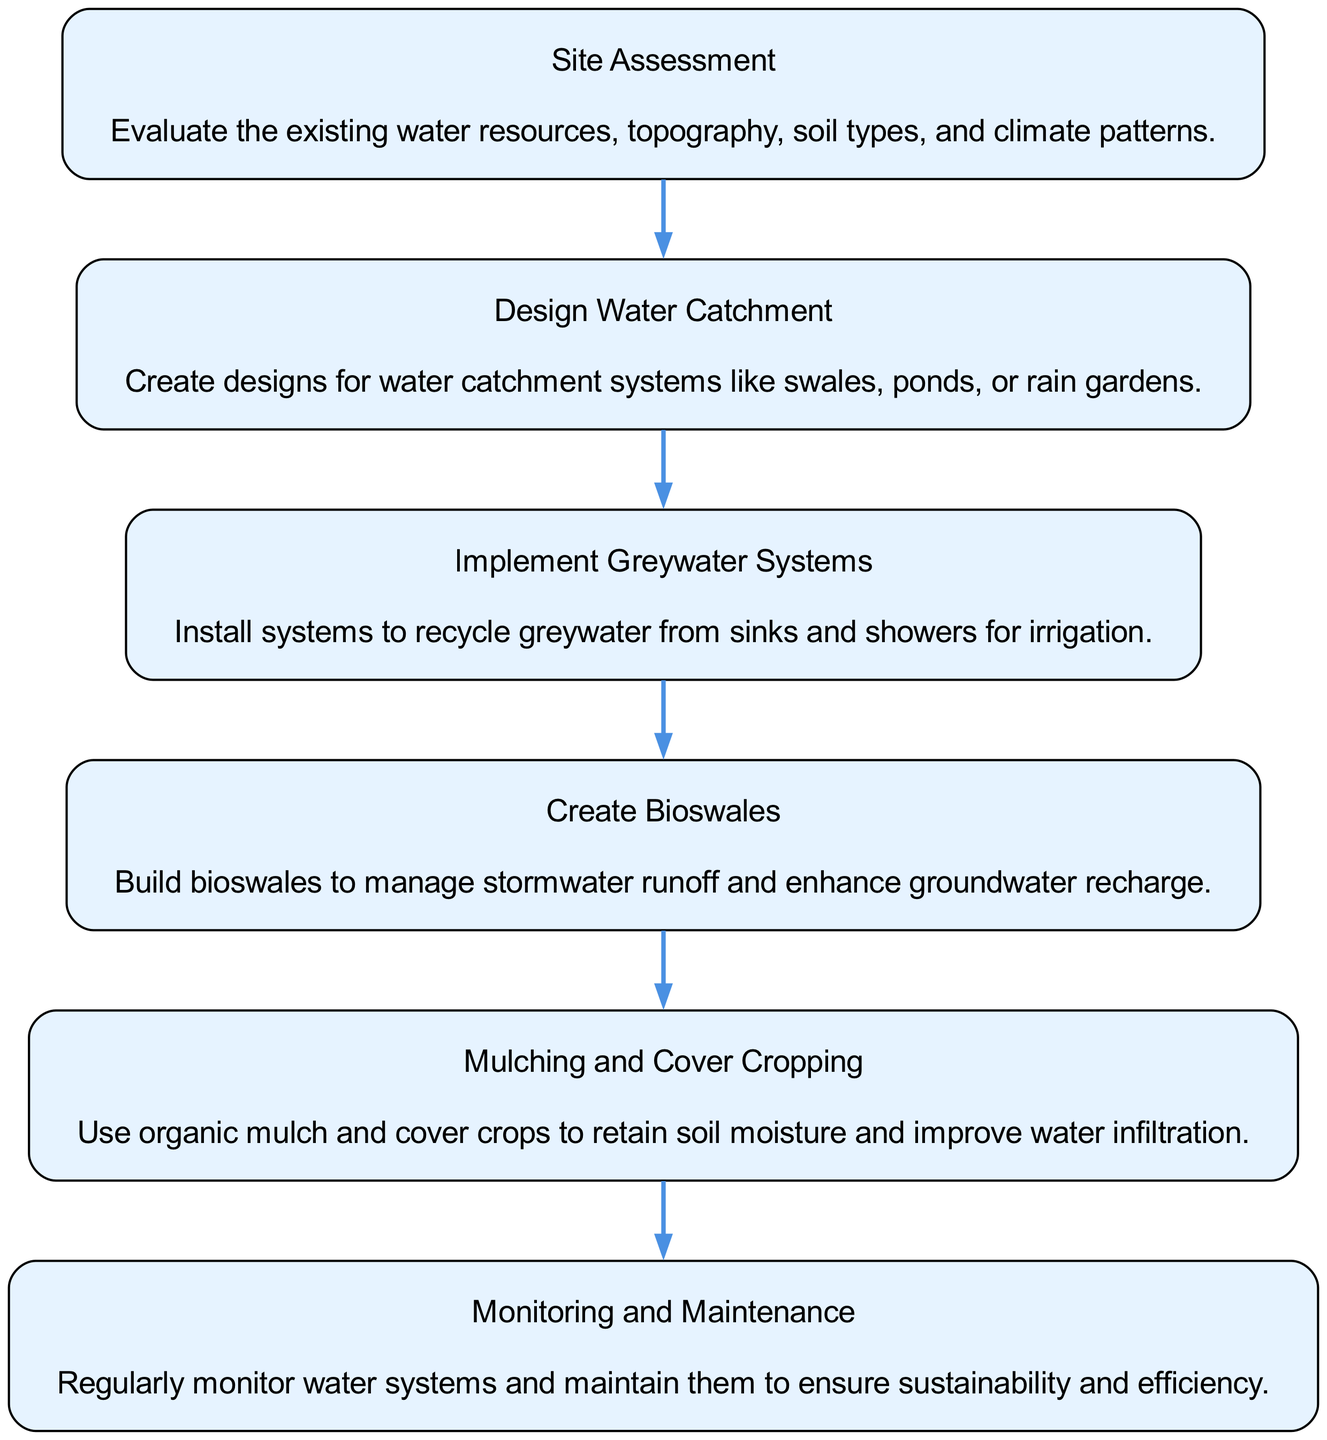What is the first step in the flow chart? The first node in the flow chart, which represents the initial action, is labeled "Site Assessment." This indicates that site assessment is the starting point of the water management system process.
Answer: Site Assessment How many steps are in the flow chart? By counting the nodes represented in the flow chart, there are a total of six distinct steps outlined. Each step is a separate node in the diagram, indicating a sequential process.
Answer: 6 What is the step following "Create Bioswales"? The step that comes directly after "Create Bioswales" in the sequence is "Mulching and Cover Cropping." This indicates that mulching and cover cropping are implemented next in the process.
Answer: Mulching and Cover Cropping What describes the action of "Implement Greywater Systems"? The action associated with "Implement Greywater Systems" is to recycle greywater from sinks and showers for irrigation. This description indicates its purpose and functionality within the water management system.
Answer: Recycle greywater for irrigation What is the relationship between "Design Water Catchment" and "Create Bioswales"? The flow chart indicates that "Design Water Catchment" leads directly to "Create Bioswales," demonstrating a sequential relationship where designing the catchment systems precedes the creation of bioswales in the overall process.
Answer: Sequential relationship What is the final step in the flow chart? The last node in the sequence of the flow chart is labeled "Monitoring and Maintenance," which indicates that this is the concluding step in the sustainable water management system process.
Answer: Monitoring and Maintenance 